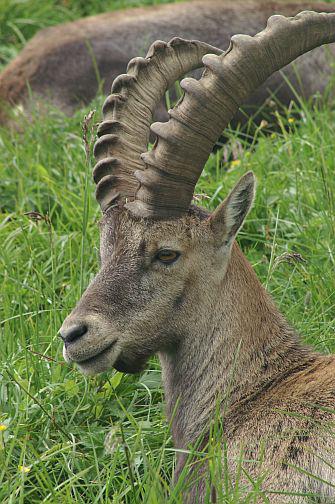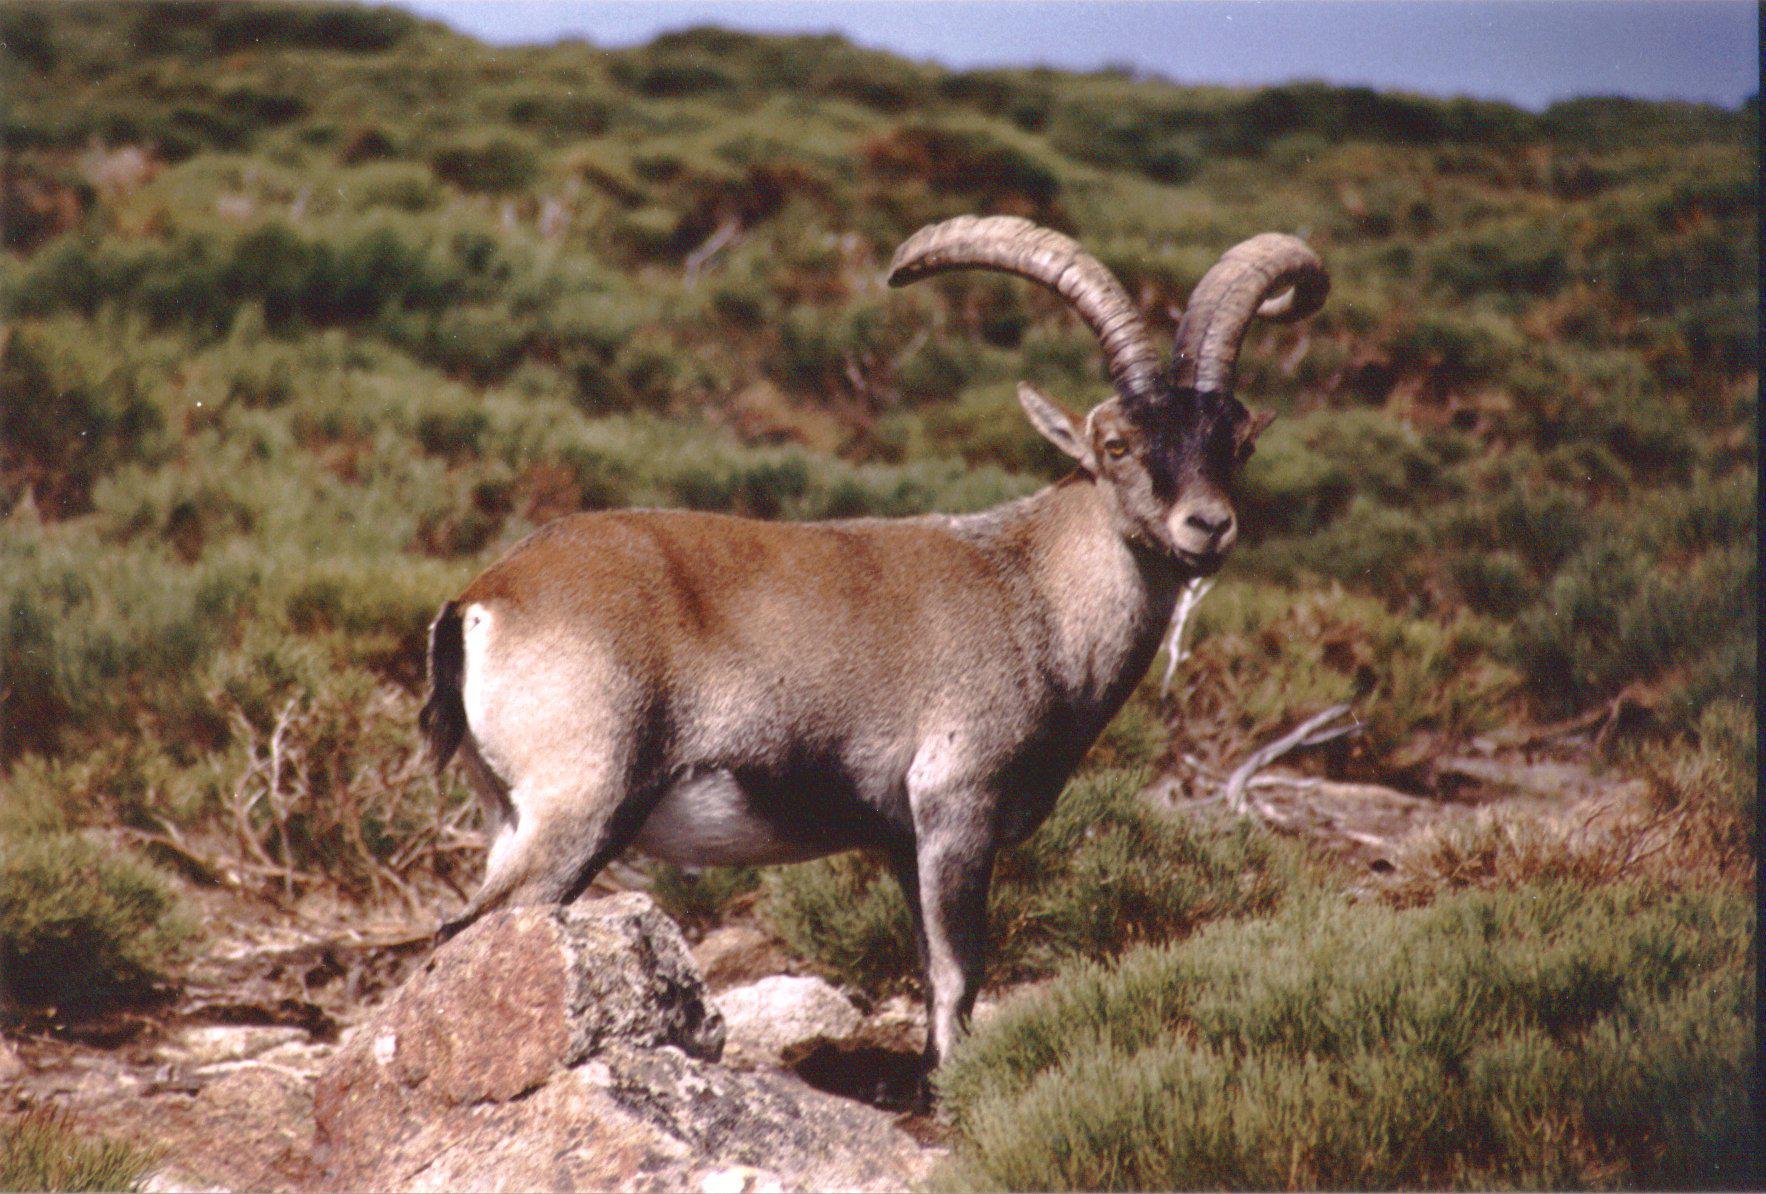The first image is the image on the left, the second image is the image on the right. Assess this claim about the two images: "An image shows two horned animals facing toward each other on a stony slope.". Correct or not? Answer yes or no. No. The first image is the image on the left, the second image is the image on the right. Examine the images to the left and right. Is the description "The right image contains two animals standing on a rock." accurate? Answer yes or no. No. 